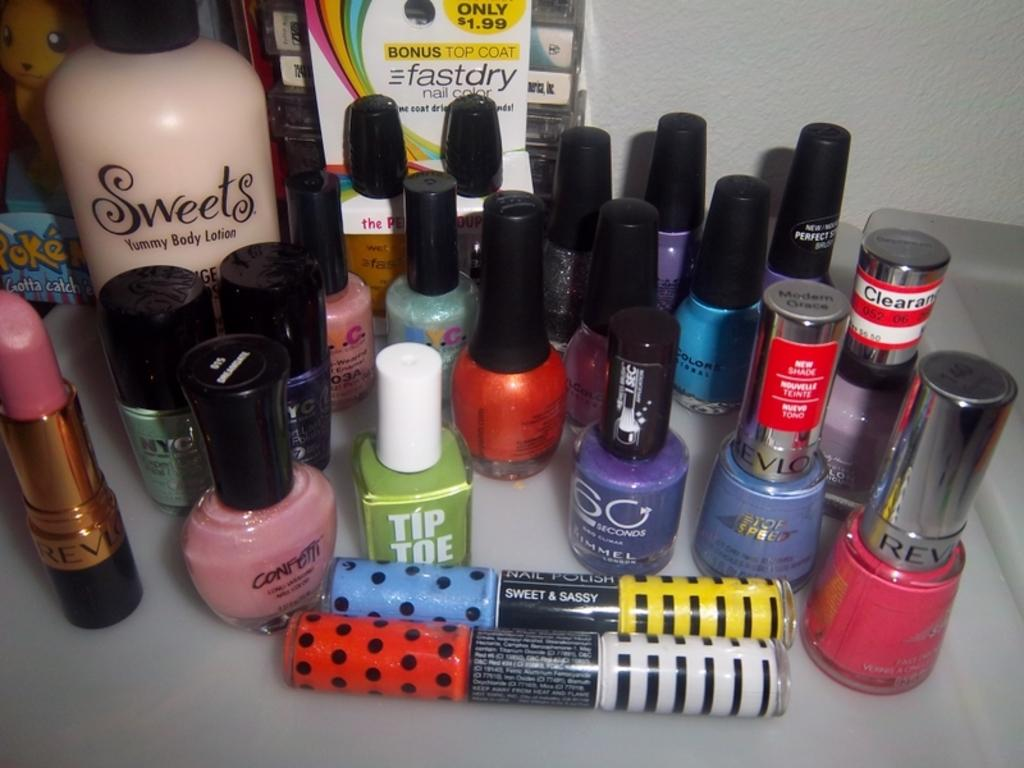<image>
Share a concise interpretation of the image provided. make up and nail polish from Tip Toe and Revlon on a table 